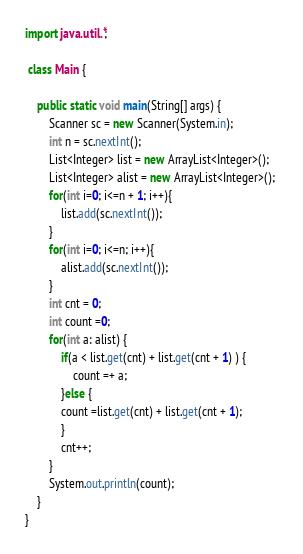Convert code to text. <code><loc_0><loc_0><loc_500><loc_500><_Java_>import java.util.*;
 
 class Main {
 
    public static void main(String[] args) {
        Scanner sc = new Scanner(System.in);
        int n = sc.nextInt();
        List<Integer> list = new ArrayList<Integer>(); 
        List<Integer> alist = new ArrayList<Integer>(); 
        for(int i=0; i<=n + 1; i++){
            list.add(sc.nextInt());      
        }
        for(int i=0; i<=n; i++){
            alist.add(sc.nextInt());      
        }
        int cnt = 0;
        int count =0;
        for(int a: alist) {
        	if(a < list.get(cnt) + list.get(cnt + 1) ) {
        		count =+ a;
        	}else {
        	count =list.get(cnt) + list.get(cnt + 1);
        	}
        	cnt++;
        }
        System.out.println(count);
    }
}</code> 